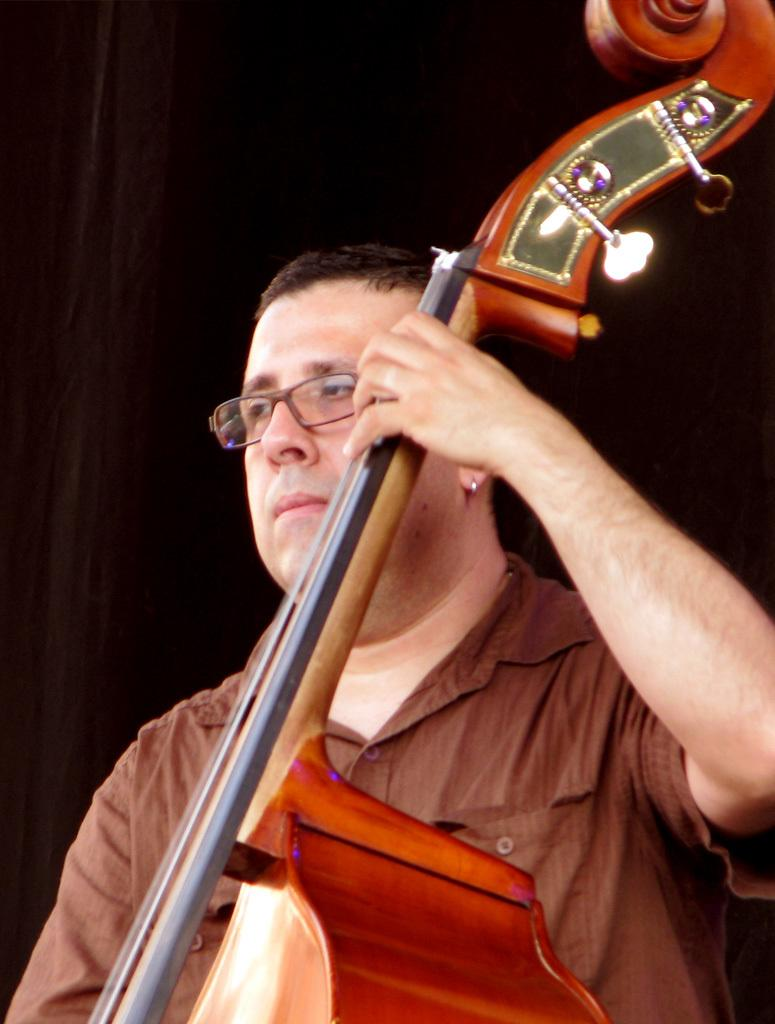What is present in the image? There is a person in the image. What is the person holding? The person is holding a musical instrument. How many trees can be seen near the bridge in the image? There is no bridge or trees present in the image; it only features a person holding a musical instrument. 